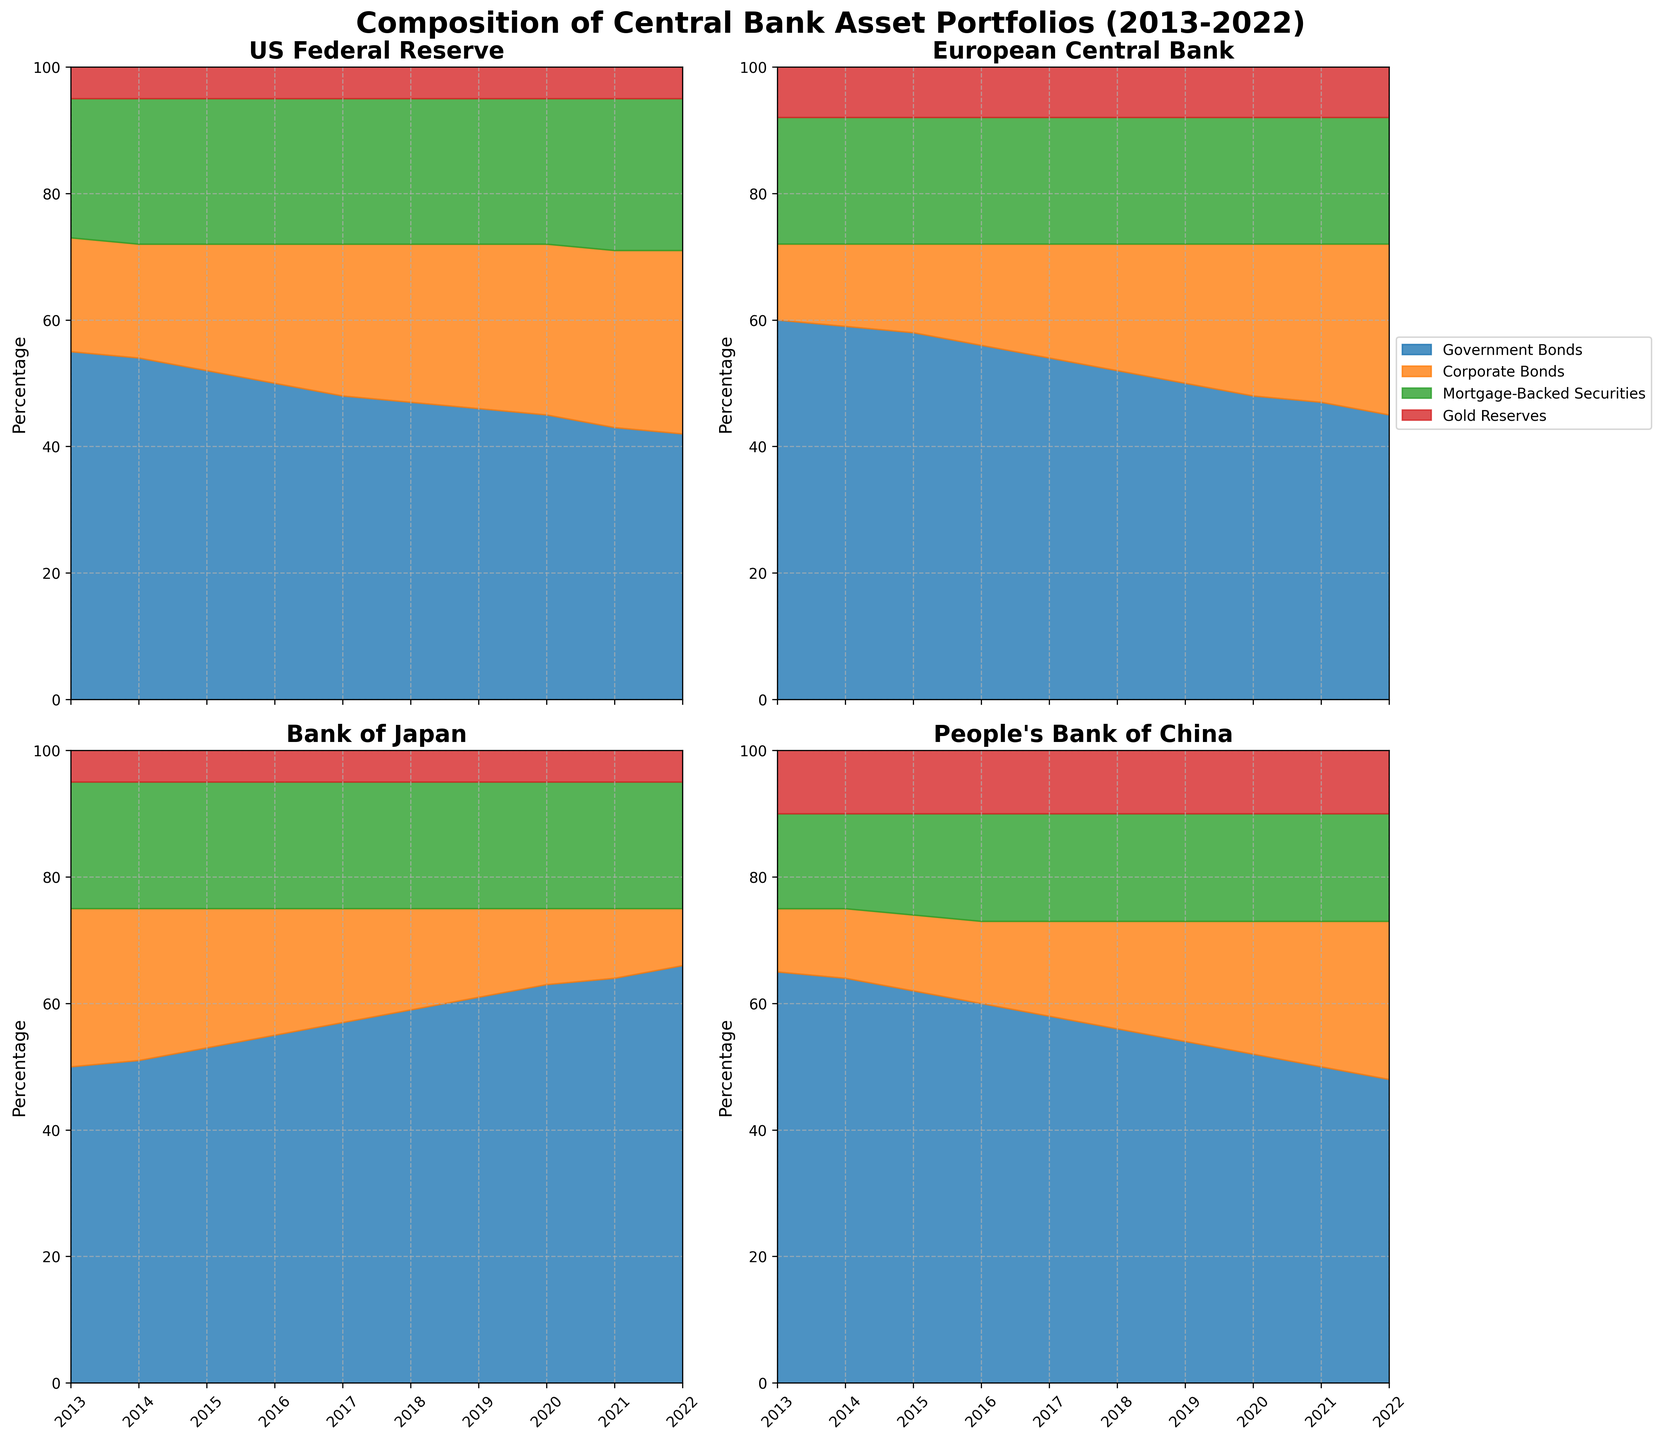What is the percentage of Government Bonds in the US Federal Reserve's portfolio in 2022? Look at the US Federal Reserve section for the year 2022, and observe the large blue area representing Government Bonds. The chart indicates that it makes up 42% of the portfolio.
Answer: 42% Which central bank had the highest percentage of Corporate Bonds in 2022? Compare the orange areas representing Corporate Bonds across all four central banks in the year 2022. The European Central Bank has the largest orange section at 27%.
Answer: European Central Bank How did the percentage of Mortgage-Backed Securities in the US Federal Reserve's portfolio change from 2013 to 2022? Look at the green area in the US Federal Reserve section for both 2013 and 2022. It increases slightly from 22% in 2013 to 24% in 2022.
Answer: Increased by 2% What is the trend of Gold Reserves held by the People's Bank of China from 2013 to 2022? Analyze the red area in the People's Bank of China section for the years 2013 to 2022. Notice that the percentage remains steady at 10% for all years.
Answer: Steady at 10% In which year did the Bank of Japan hold the highest percentage of Government Bonds? Observe the blue area in the Bank of Japan section for all years. The largest blue area is in 2022, where Government Bonds make up 66% of the portfolio.
Answer: 2022 What major shift occurred in the composition of the European Central Bank’s asset portfolio between 2014 and 2015? Compare the European Central Bank's sections for 2014 and 2015. Note the shift in the orange area (Corporate Bonds) which increased from 13% to 14% and the blue area (Government Bonds) which decreased from 59% to 58%.
Answer: Increase in Corporate Bonds, Decrease in Government Bonds Which central bank has the most diversified asset portfolio in 2022? Look at the proportions of asset types for each central bank in 2022. The US Federal Reserve has the most evenly distributed areas between the asset types.
Answer: US Federal Reserve How did the allocation of Government Bonds change for the People's Bank of China from 2013 to 2022? Look at the blue area in the People's Bank of China section for the years 2013 and 2022. The percentage of Government Bonds decreases from 65% in 2013 to 48% in 2022.
Answer: Decreased by 17% What is the common trend observed in the Corporate Bonds segment for all central banks from 2013 to 2022? Examine the orange areas for all central banks across all years. Notice that the percentage of Corporate Bonds generally increases for all central banks.
Answer: Generally increases Compare the Mortgage-Backed Securities allocation in the Bank of Japan's portfolio between 2013 and 2022. Look at the green area in the Bank of Japan section for the years 2013 and 2022. The percentage of Mortgage-Backed Securities remains consistent at 20% for both years.
Answer: Consistent at 20% 